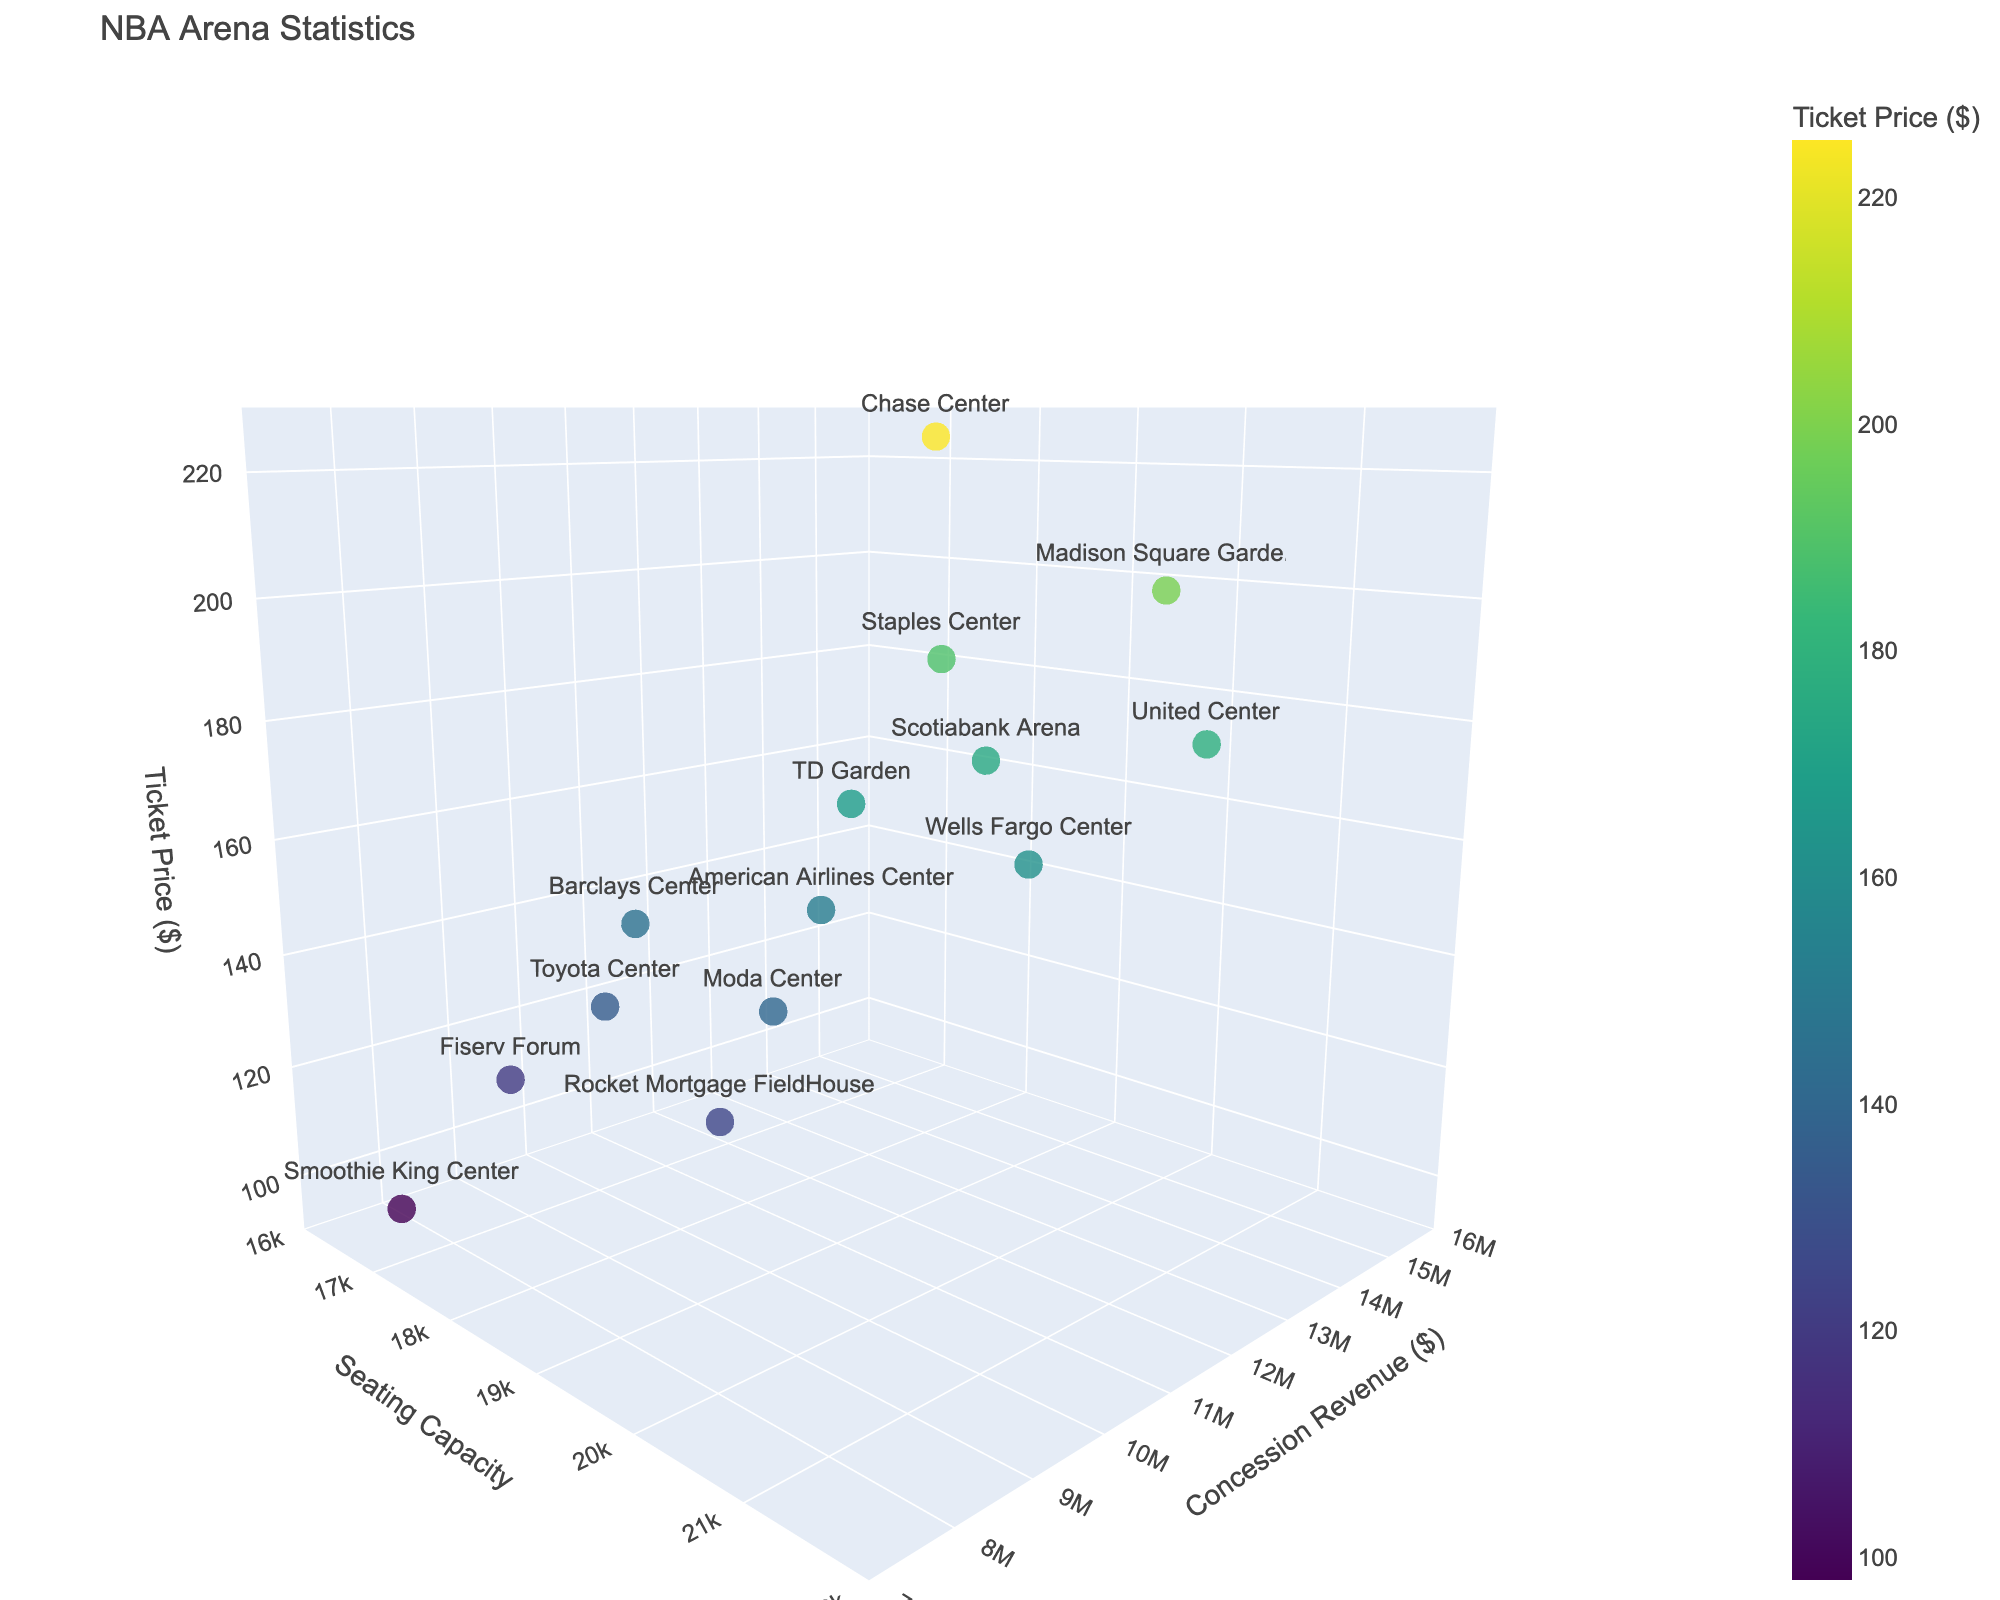What's the seating capacity of the Staples Center? Look at the figure and find the point labeled "Staples Center." Check the value on the x-axis (Seating Capacity) for this point.
Answer: 19068 Which arena has the highest concession revenue? Identify the point with the highest y-value on the chart, which represents concession revenue. The label of this point will give the arena's name.
Answer: Madison Square Garden What is the range of ticket prices among the arenas? Find the minimum and maximum values on the z-axis (Ticket Price). The minimum ticket price is represented by the lowest z-value, and the maximum by the highest z-value. The range is the difference between these values.
Answer: 127 (225 - 98) Which arena has the largest seating capacity and what is its ticket price? Identify the point with the highest x-value on the chart (Seating Capacity). The z-value of this point represents the ticket price.
Answer: United Center, 178 Compare the concession revenue of Chase Center and Scotiabank Arena. Which one is higher and by how much? Find the points labeled "Chase Center" and "Scotiabank Arena" and compare their y-values (Concession Revenue). Calculate the difference.
Answer: Chase Center by $2,000,000 (14000000 - 12000000) What's the average seating capacity of all arenas? Sum all seating capacity values and divide by the number of arenas (14 in total). (19068 + 19812 + 17732 + 19156 + 20917 + 19200 + 18055 + 18064 + 17341 + 16867 + 20478 + 19800 + 19441 + 19432) / 14 = 19209 (rounded)
Answer: 19209 Which arena has the lowest ticket price, and what are its seating capacity and concession revenue? Find the point with the lowest z-value (Ticket Price) and note its x and y values for seating capacity and concession revenue, respectively.
Answer: Smoothie King Center, Capacity: 16867, Revenue: $7,500,000 How does seating capacity correlate with ticket prices? Observe the relationship between the x-values (Seating Capacity) and z-values (Ticket Price). Consider whether higher capacities generally correspond to higher, lower, or similar ticket prices.
Answer: No clear correlation What's the total concession revenue of all arenas combined? Sum the y-values (Concession Revenue) of all points. (12500000 + 15000000 + 9800000 + 11000000 + 13500000 + 10500000 + 9000000 + 14000000 + 8500000 + 7500000 + 11500000 + 12000000 + 9500000 + 8800000) = 154300000
Answer: $154300000 Which arena combines the highest ticket price and highest seating capacity? Look for the point with the highest combined sum of x and z values (Seating Capacity + Ticket Price).
Answer: Chase Center ($225 + 18064 = 18289) 